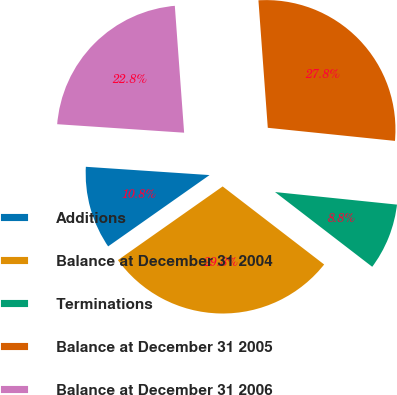Convert chart to OTSL. <chart><loc_0><loc_0><loc_500><loc_500><pie_chart><fcel>Additions<fcel>Balance at December 31 2004<fcel>Terminations<fcel>Balance at December 31 2005<fcel>Balance at December 31 2006<nl><fcel>10.82%<fcel>29.81%<fcel>8.8%<fcel>27.8%<fcel>22.77%<nl></chart> 